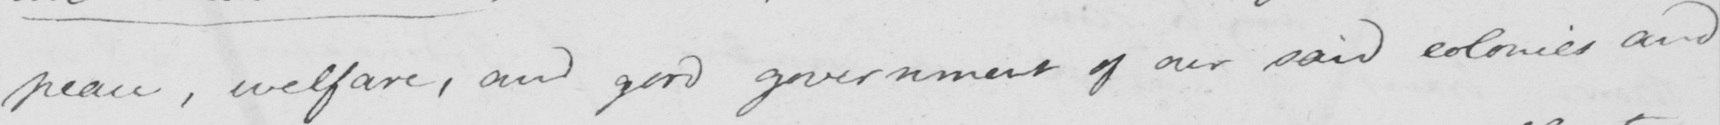Can you read and transcribe this handwriting? peace , welfare , and good government of our said colonies and 